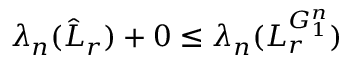<formula> <loc_0><loc_0><loc_500><loc_500>\lambda _ { n } ( \hat { L } _ { r } ) + 0 \leq \lambda _ { n } ( L _ { r } ^ { G _ { 1 } ^ { n } } )</formula> 